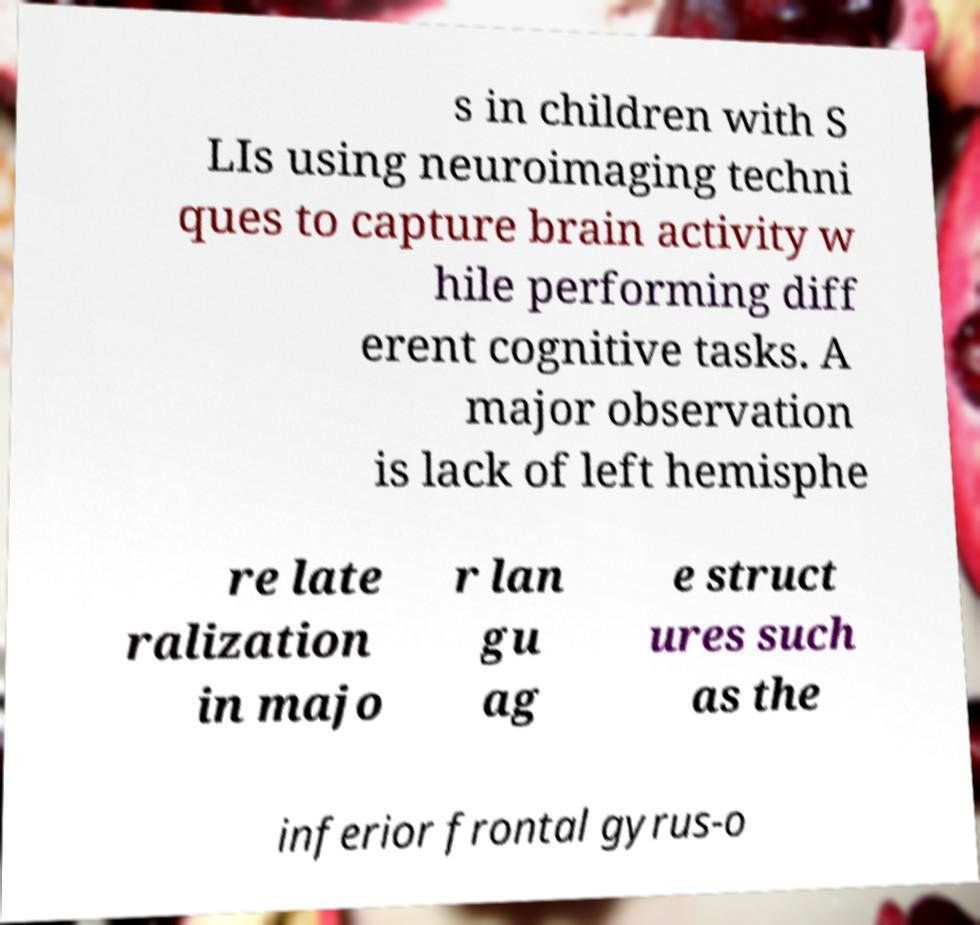Could you extract and type out the text from this image? s in children with S LIs using neuroimaging techni ques to capture brain activity w hile performing diff erent cognitive tasks. A major observation is lack of left hemisphe re late ralization in majo r lan gu ag e struct ures such as the inferior frontal gyrus-o 